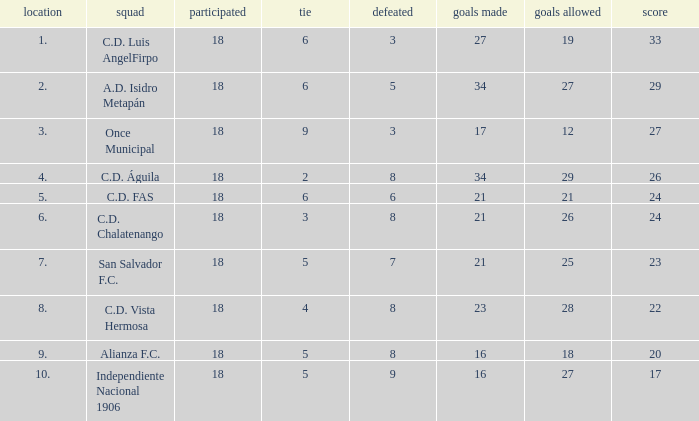How many points were in a game that had a lost of 5, greater than place 2, and 27 goals conceded? 0.0. 